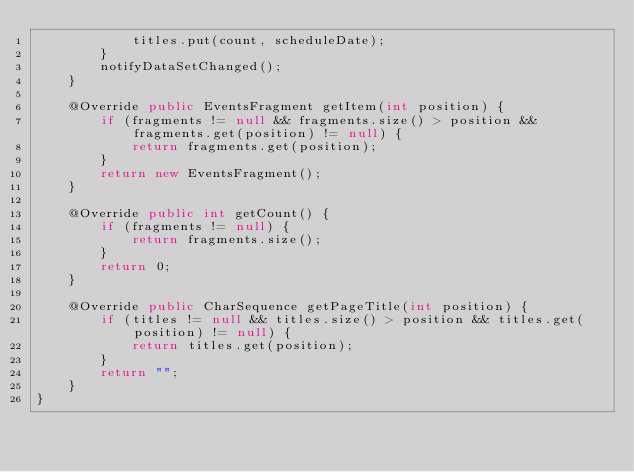<code> <loc_0><loc_0><loc_500><loc_500><_Java_>            titles.put(count, scheduleDate);
        }
        notifyDataSetChanged();
    }

    @Override public EventsFragment getItem(int position) {
        if (fragments != null && fragments.size() > position && fragments.get(position) != null) {
            return fragments.get(position);
        }
        return new EventsFragment();
    }

    @Override public int getCount() {
        if (fragments != null) {
            return fragments.size();
        }
        return 0;
    }

    @Override public CharSequence getPageTitle(int position) {
        if (titles != null && titles.size() > position && titles.get(position) != null) {
            return titles.get(position);
        }
        return "";
    }
}
</code> 